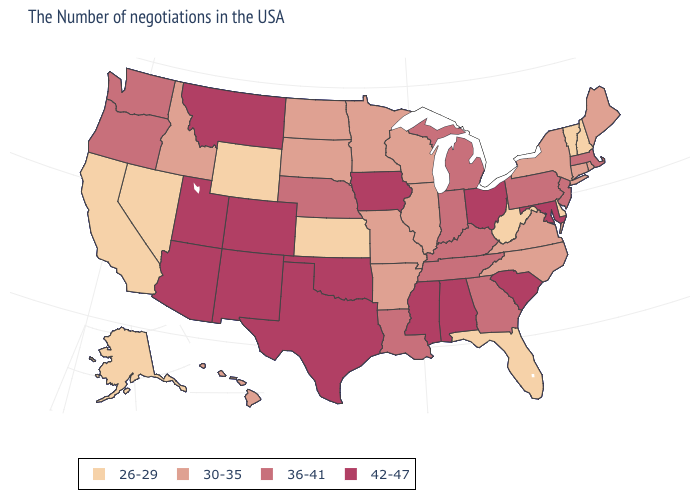What is the value of New Hampshire?
Short answer required. 26-29. How many symbols are there in the legend?
Give a very brief answer. 4. What is the highest value in the MidWest ?
Keep it brief. 42-47. What is the value of Georgia?
Keep it brief. 36-41. What is the lowest value in states that border Colorado?
Give a very brief answer. 26-29. What is the value of Vermont?
Short answer required. 26-29. Is the legend a continuous bar?
Concise answer only. No. Does the map have missing data?
Quick response, please. No. Name the states that have a value in the range 36-41?
Concise answer only. Massachusetts, New Jersey, Pennsylvania, Georgia, Michigan, Kentucky, Indiana, Tennessee, Louisiana, Nebraska, Washington, Oregon. Does Indiana have a higher value than Alabama?
Answer briefly. No. Does the map have missing data?
Concise answer only. No. Which states have the lowest value in the West?
Answer briefly. Wyoming, Nevada, California, Alaska. Is the legend a continuous bar?
Write a very short answer. No. What is the lowest value in the USA?
Concise answer only. 26-29. Which states have the highest value in the USA?
Concise answer only. Maryland, South Carolina, Ohio, Alabama, Mississippi, Iowa, Oklahoma, Texas, Colorado, New Mexico, Utah, Montana, Arizona. 